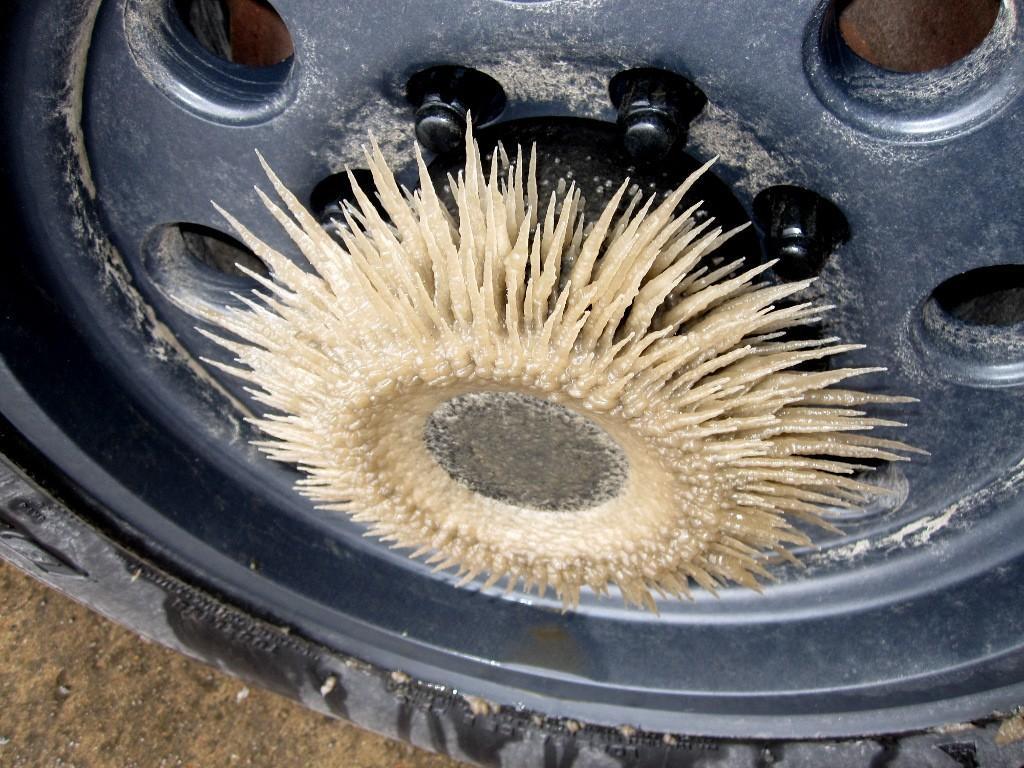Can you describe this image briefly? This image consists of a wheel in black color along with the bolts. At the bottom, there is ground. In the front, we can see an object which has sharp edges. 